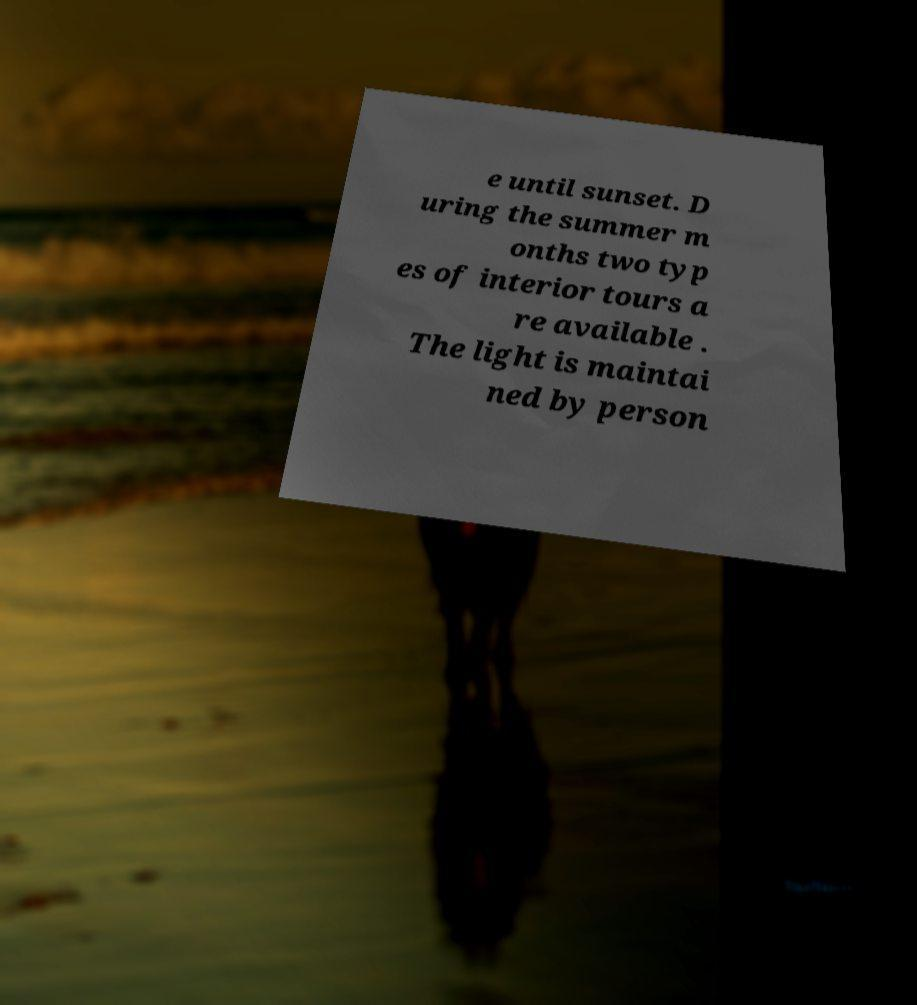There's text embedded in this image that I need extracted. Can you transcribe it verbatim? e until sunset. D uring the summer m onths two typ es of interior tours a re available . The light is maintai ned by person 